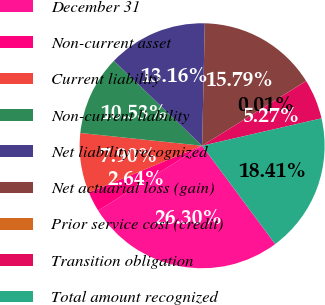Convert chart to OTSL. <chart><loc_0><loc_0><loc_500><loc_500><pie_chart><fcel>December 31<fcel>Non-current asset<fcel>Current liability<fcel>Non-current liability<fcel>Net liability recognized<fcel>Net actuarial loss (gain)<fcel>Prior service cost (credit)<fcel>Transition obligation<fcel>Total amount recognized<nl><fcel>26.31%<fcel>2.64%<fcel>7.9%<fcel>10.53%<fcel>13.16%<fcel>15.79%<fcel>0.01%<fcel>5.27%<fcel>18.42%<nl></chart> 